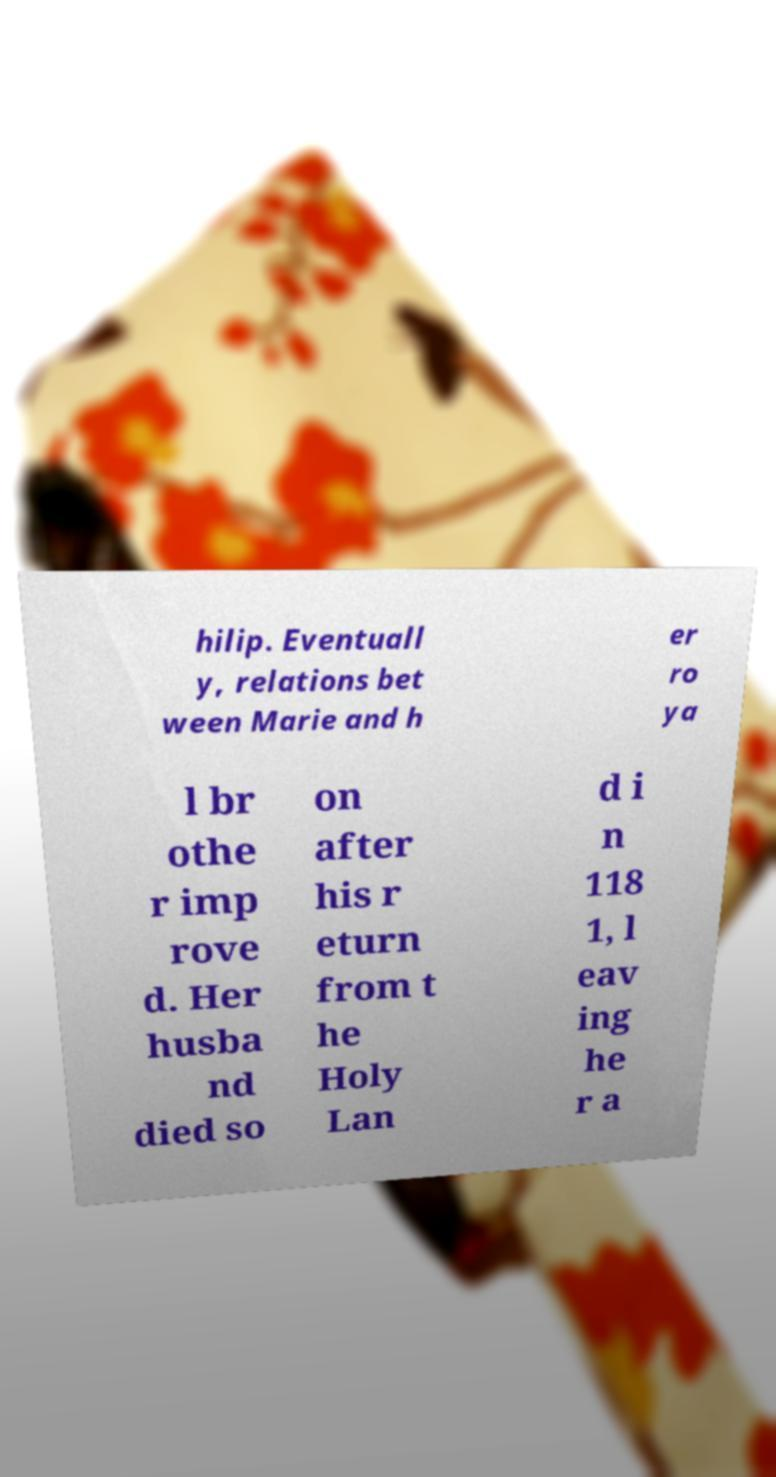There's text embedded in this image that I need extracted. Can you transcribe it verbatim? hilip. Eventuall y, relations bet ween Marie and h er ro ya l br othe r imp rove d. Her husba nd died so on after his r eturn from t he Holy Lan d i n 118 1, l eav ing he r a 